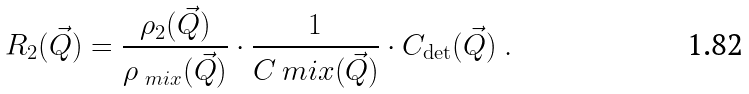<formula> <loc_0><loc_0><loc_500><loc_500>R _ { 2 } ( \vec { Q } ) = \frac { \rho _ { 2 } ( \vec { Q } ) } { \rho _ { \ m i x } ( \vec { Q } ) } \cdot \frac { 1 } { C _ { \ } m i x ( \vec { Q } ) } \cdot C _ { \det } ( \vec { Q } ) \ .</formula> 